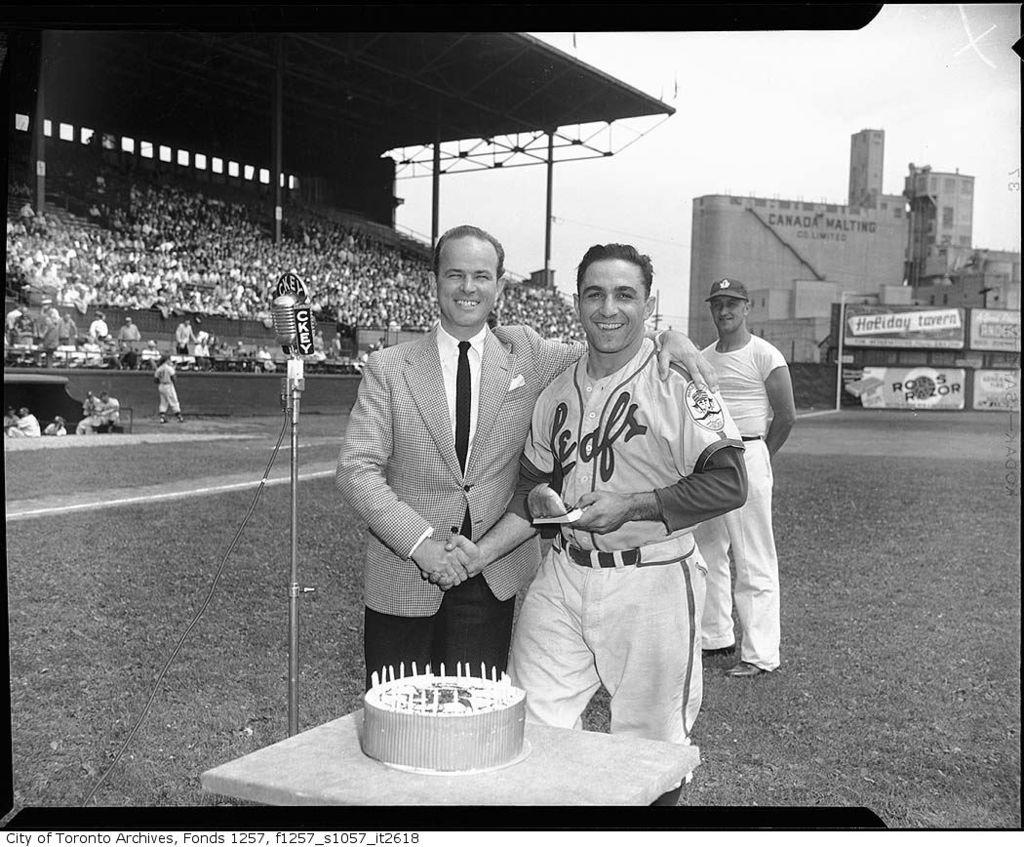Provide a one-sentence caption for the provided image. The player in the jersey is plating for the Leafs. 